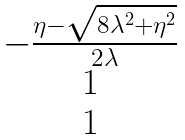<formula> <loc_0><loc_0><loc_500><loc_500>\begin{matrix} - \frac { \eta - \sqrt { 8 \lambda ^ { 2 } + \eta ^ { 2 } } } { 2 \lambda } \\ 1 \\ 1 \end{matrix}</formula> 